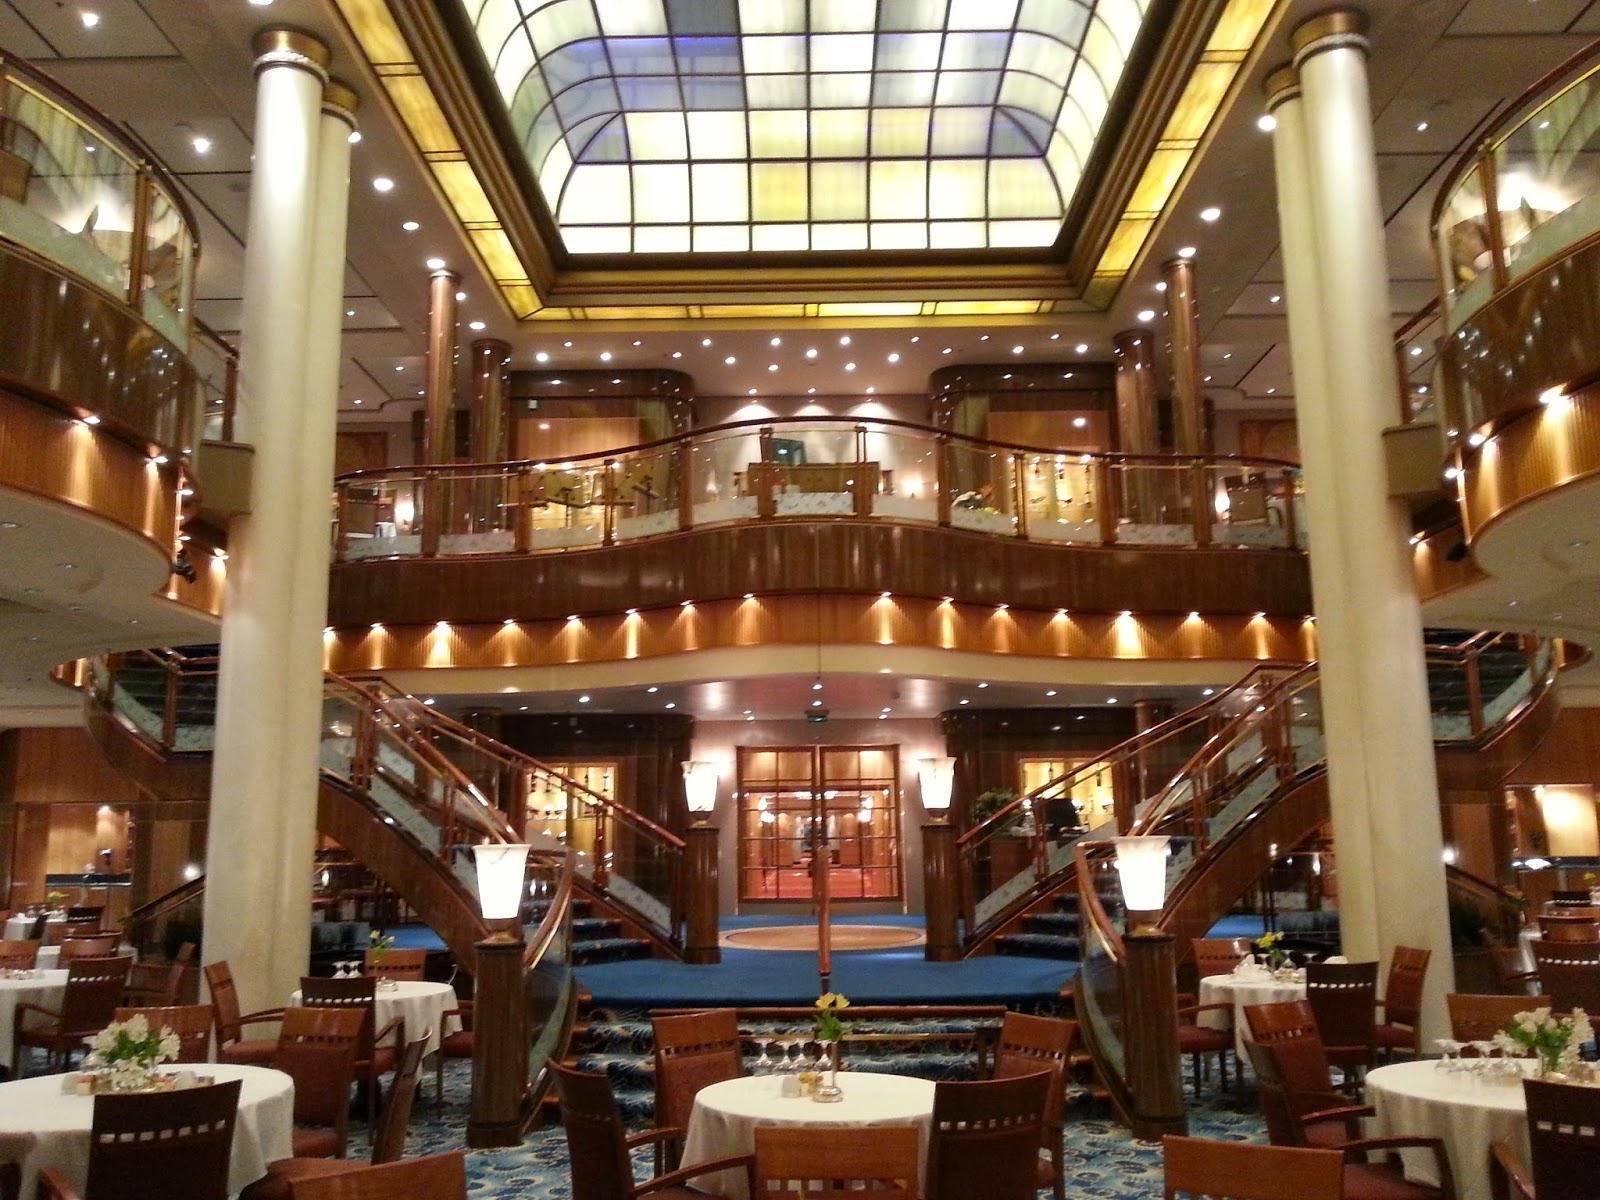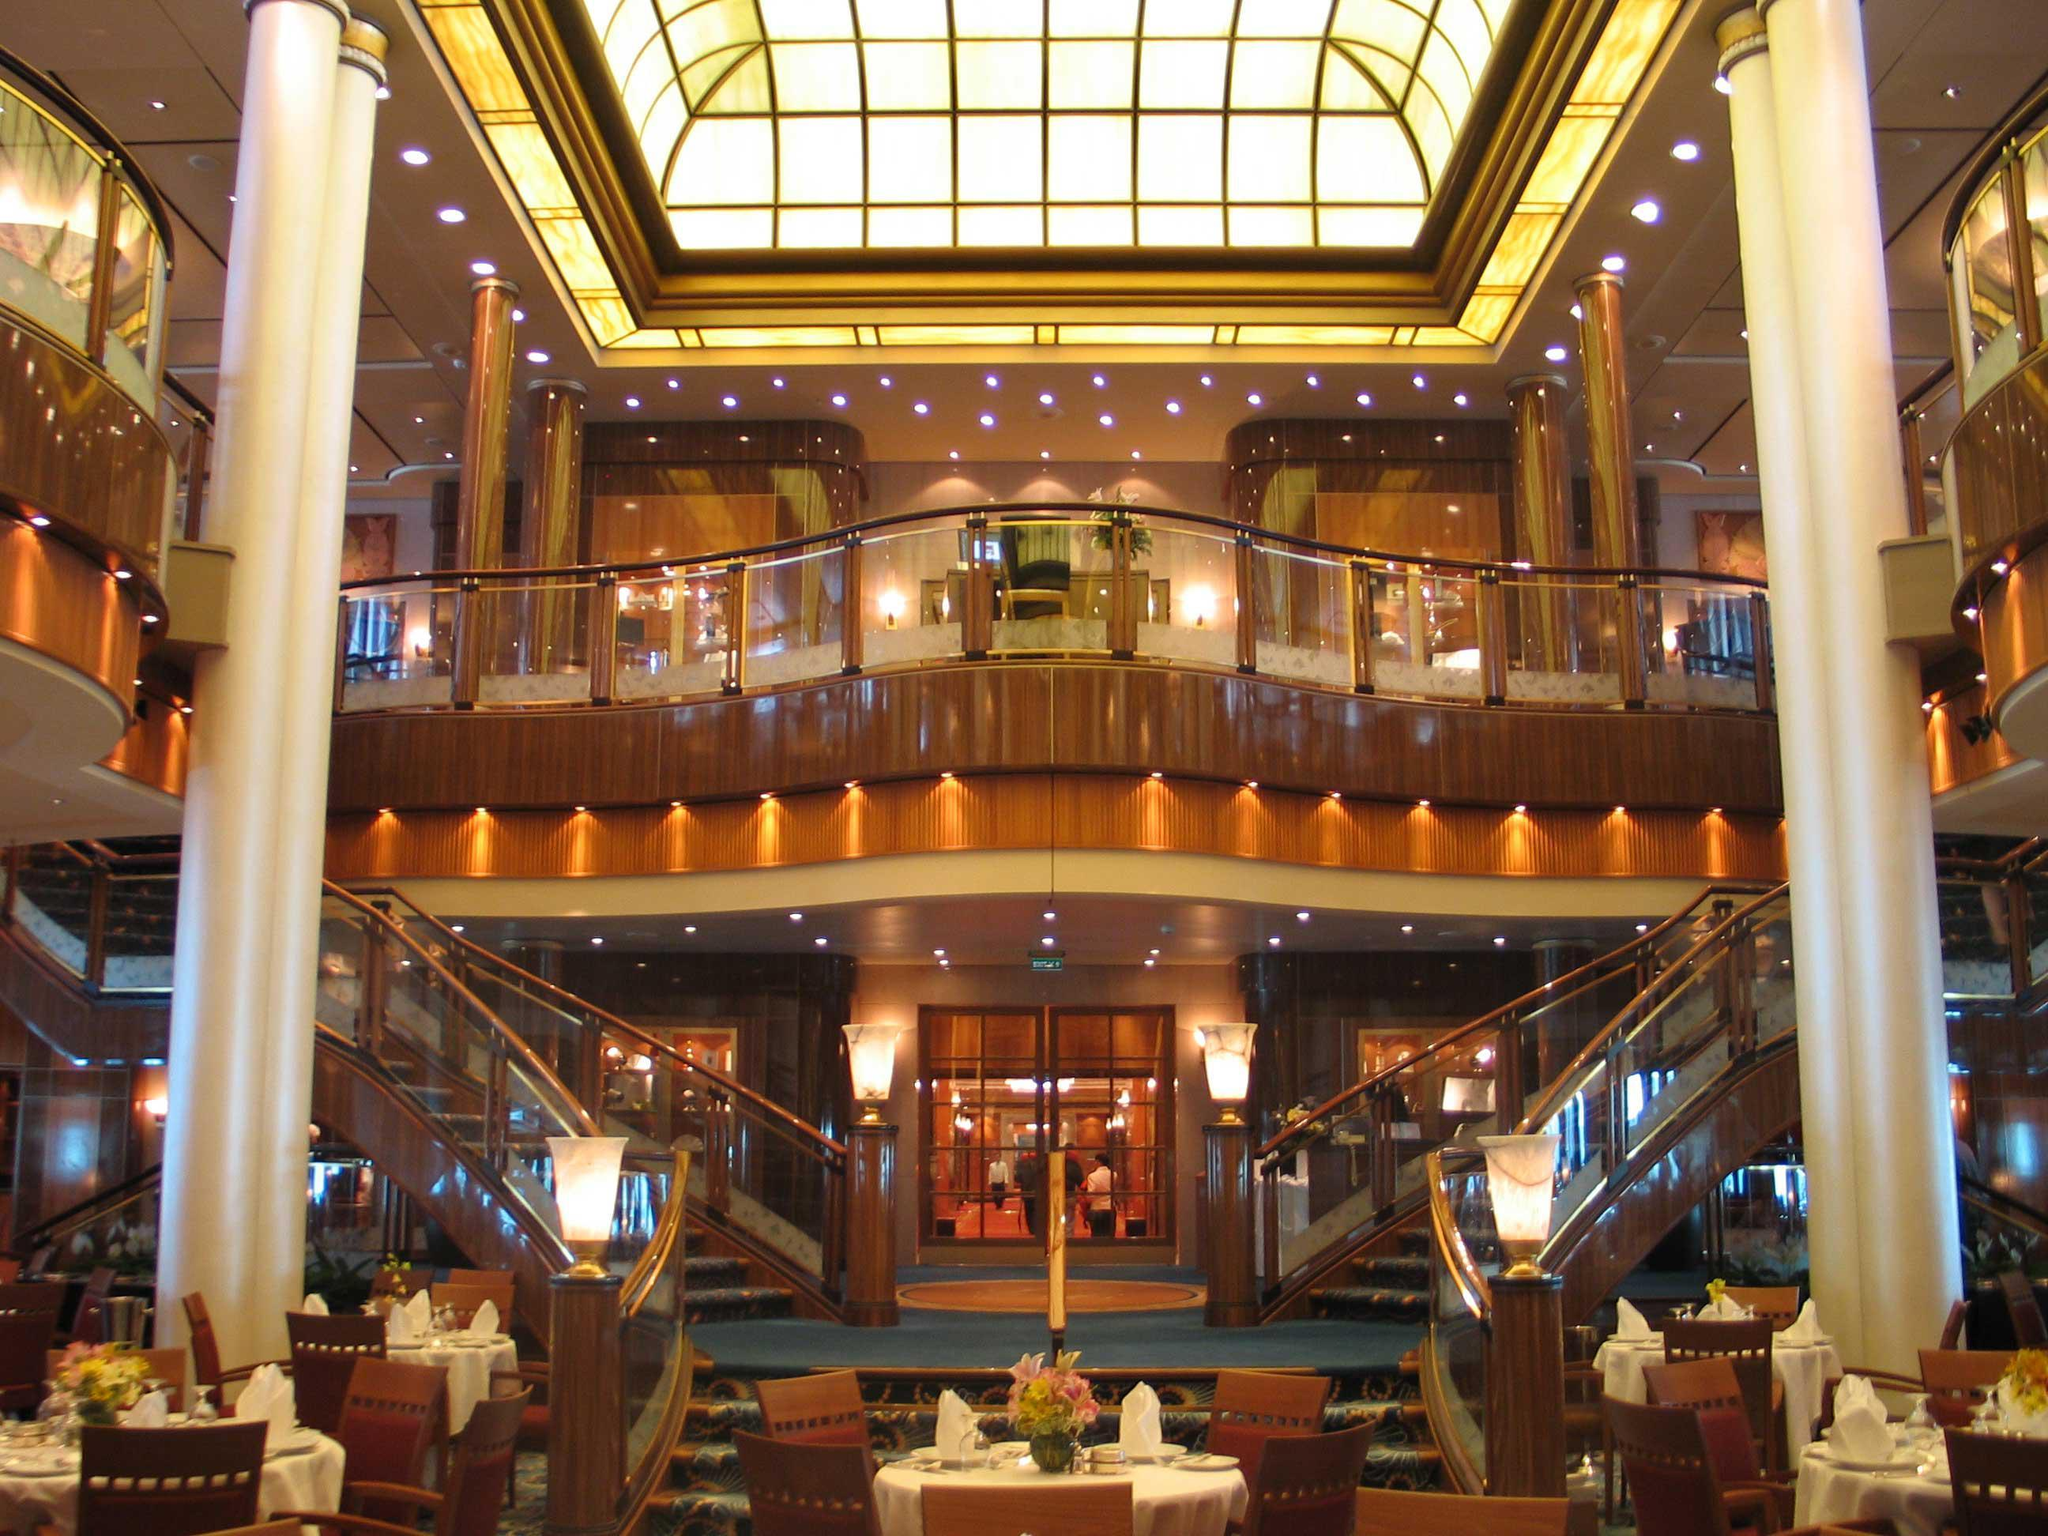The first image is the image on the left, the second image is the image on the right. Analyze the images presented: Is the assertion "One of the images has chairs with red upholstery and white backs." valid? Answer yes or no. No. The first image is the image on the left, the second image is the image on the right. Analyze the images presented: Is the assertion "There is a large skylight visible in at least one of the images." valid? Answer yes or no. Yes. 